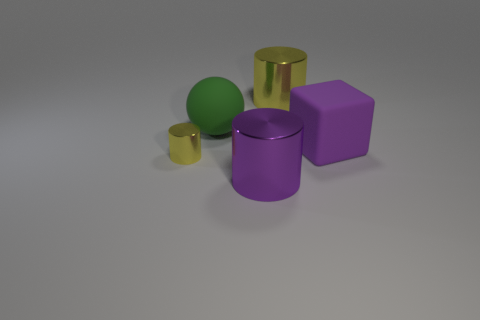Is there any significance to the arrangement of the objects in the image? Without additional context, the significance is open to interpretation. It could be a study in three-dimensional forms, illustrating contrast in colors and shapes, or it may be set up this way for a visual exercise or to showcase rendering techniques. Each object's placement allows it to be distinctly observed, minimizing overlap and providing a clear view of their geometric forms.  What can be inferred about the lighting in the scene? The lighting in the scene looks diffused with relatively soft shadows, suggesting an overhead or ambient light source. This type of lighting minimizes harsh shadows and helps to accentuate the colors and textures of the objects. 